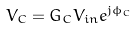<formula> <loc_0><loc_0><loc_500><loc_500>V _ { C } = G _ { C } V _ { i n } e ^ { j \phi _ { C } }</formula> 